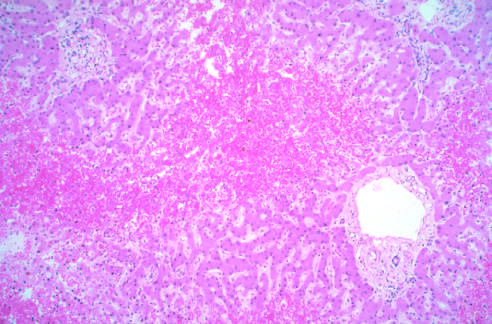re bronchial biopsy specimen from an asthmatic patient intact?
Answer the question using a single word or phrase. No 